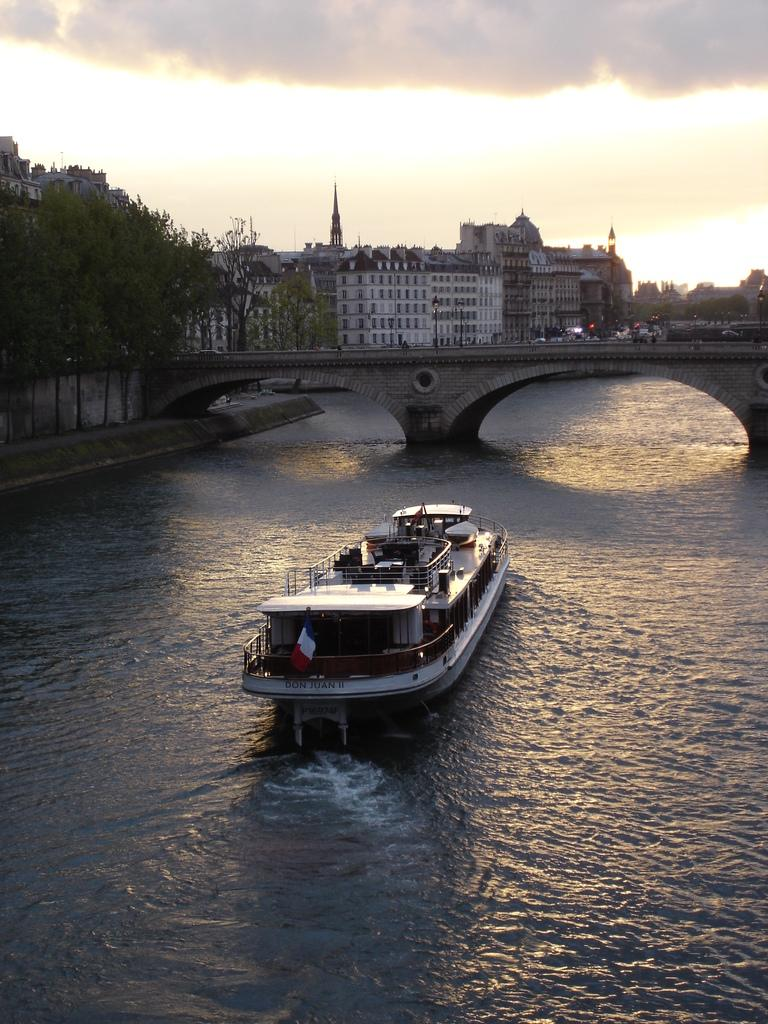What is the main subject in the center of the image? There is a ship in the center of the image. Where is the ship located? The ship is on the water. What can be seen in the background of the image? There is a bridge, trees, buildings, lights, and the sky visible in the background of the image. What is the condition of the sky in the image? The sky is visible in the background of the image, and there are clouds present. Can you tell me how many girls are walking with a kettle in the image? There are no girls or kettles present in the image; it features a ship on the water with various background elements. 